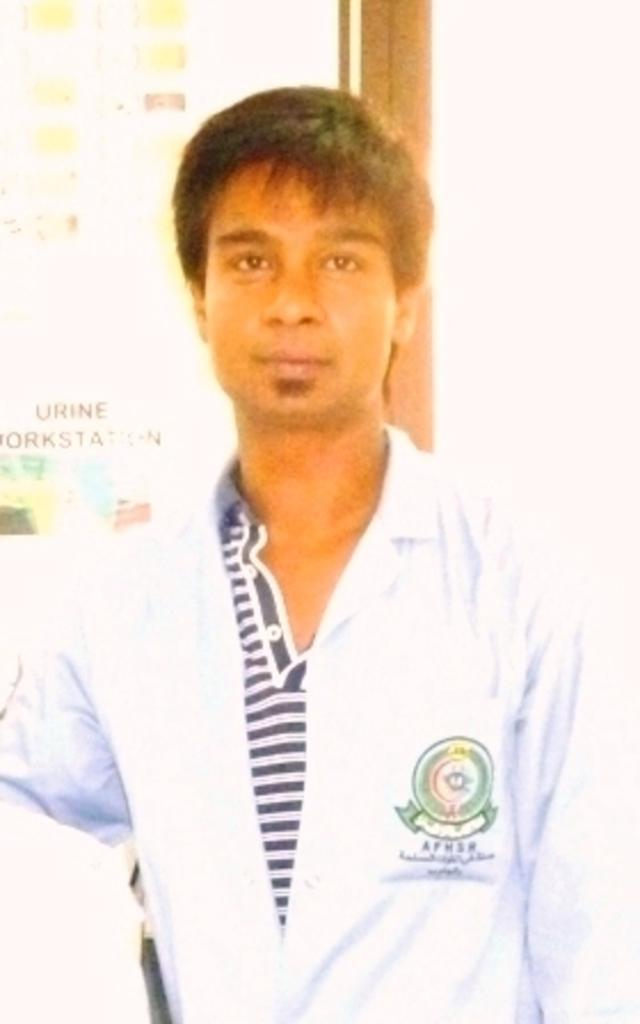What is the main subject of the image? The main subject of the image is a man standing. Can you describe anything in the background of the image? Yes, there is a board in the background of the image. How many boys are on the journey depicted in the image? There is no journey or boys present in the image; it features a man standing and a board in the background. 